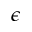<formula> <loc_0><loc_0><loc_500><loc_500>\epsilon</formula> 